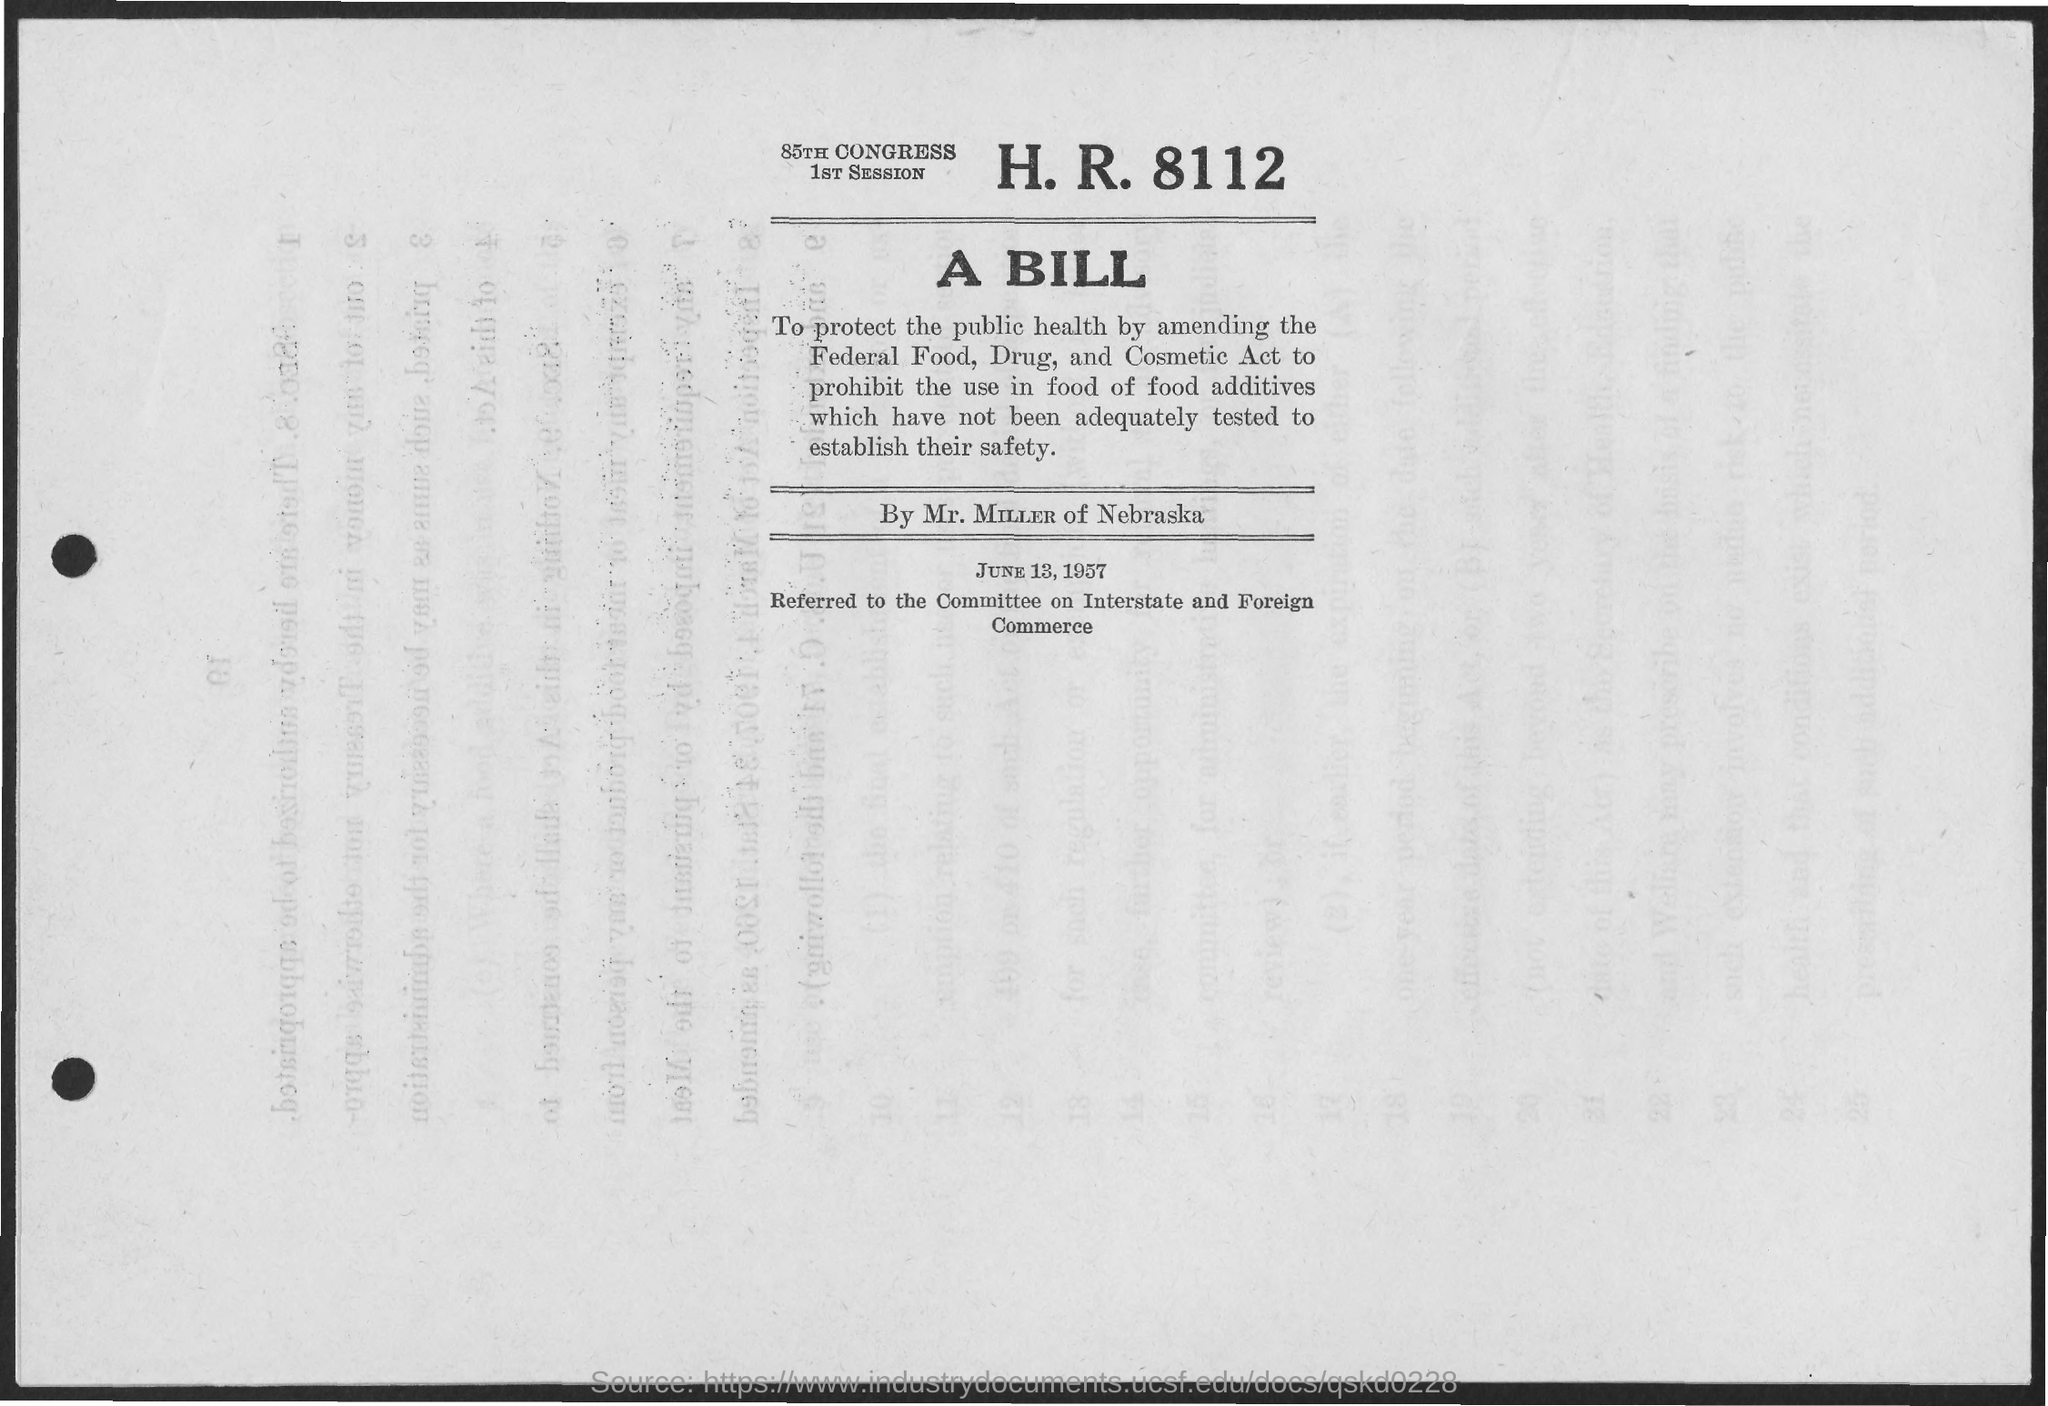Identify some key points in this picture. The document is dated June 13, 1957. 